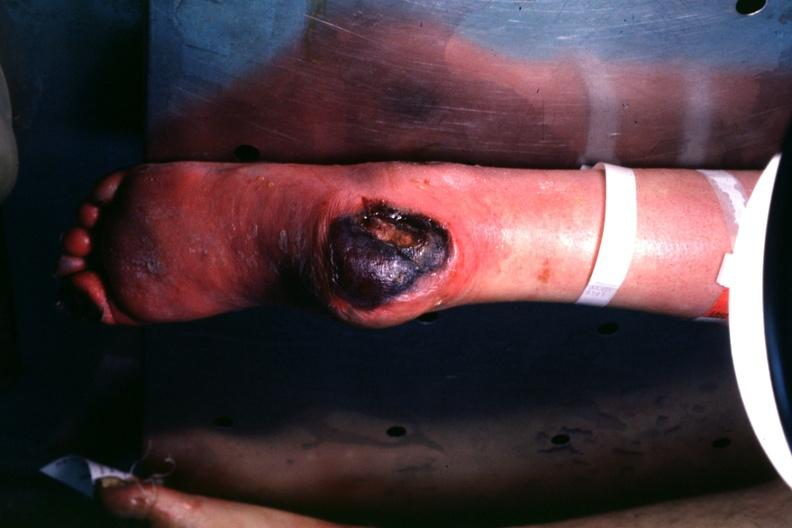does this image show good example of this diabetic lesion va.?
Answer the question using a single word or phrase. Yes 